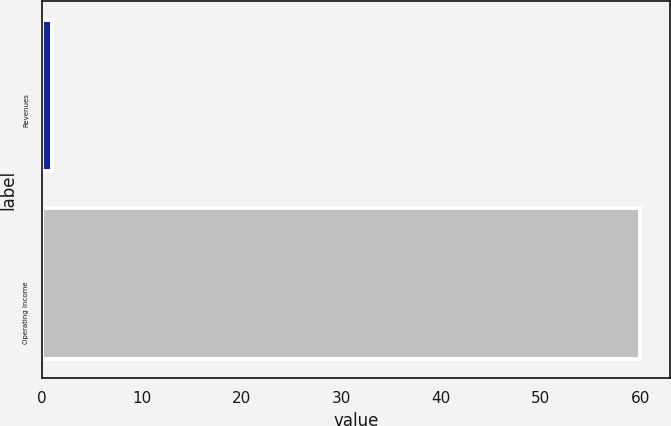Convert chart. <chart><loc_0><loc_0><loc_500><loc_500><bar_chart><fcel>Revenues<fcel>Operating income<nl><fcel>1<fcel>60<nl></chart> 